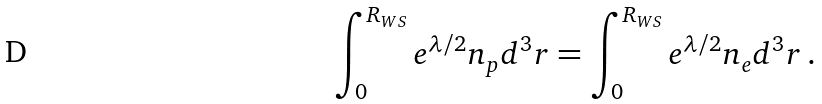<formula> <loc_0><loc_0><loc_500><loc_500>\int _ { 0 } ^ { R _ { W S } } e ^ { \lambda / 2 } n _ { p } d ^ { 3 } r = \int _ { 0 } ^ { R _ { W S } } e ^ { \lambda / 2 } n _ { e } d ^ { 3 } r \, .</formula> 